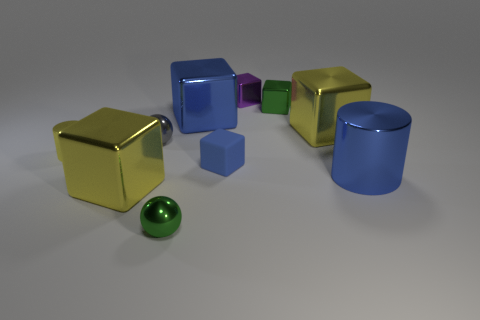There is a tiny metallic ball that is behind the small matte object; does it have the same color as the big cube that is in front of the blue rubber thing?
Give a very brief answer. No. Are there any small purple shiny cubes to the right of the tiny rubber block?
Provide a short and direct response. Yes. The big metallic thing that is left of the green metal block and in front of the yellow metallic cylinder is what color?
Keep it short and to the point. Yellow. Is there another small metal cylinder that has the same color as the tiny cylinder?
Your answer should be very brief. No. Do the cylinder right of the tiny blue cube and the blue thing behind the tiny yellow object have the same material?
Provide a short and direct response. Yes. There is a gray object that is behind the blue cylinder; what size is it?
Ensure brevity in your answer.  Small. What size is the green ball?
Make the answer very short. Small. How big is the cylinder that is to the right of the yellow metallic cube right of the cube that is behind the small green metallic cube?
Offer a terse response. Large. Are there any gray spheres that have the same material as the tiny blue object?
Offer a very short reply. No. What is the shape of the small purple shiny object?
Give a very brief answer. Cube. 